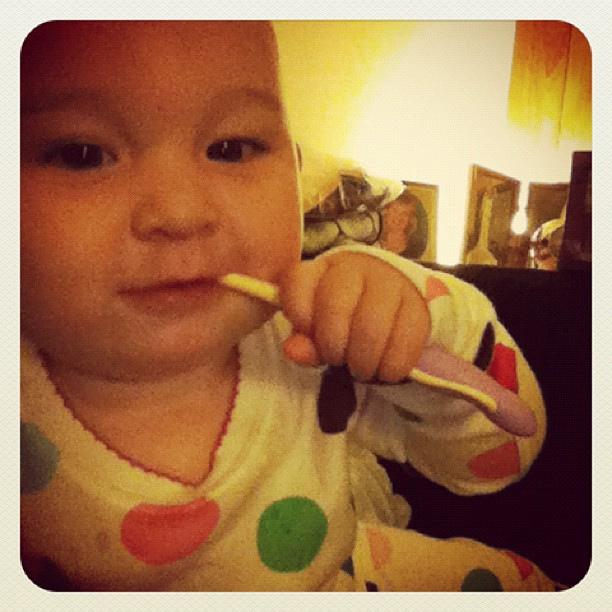Is the baby looking directly into the camera?
Be succinct. Yes. What color hair does the lady have in the framed picture behind the baby?
Quick response, please. Blonde. Is this black and white?
Be succinct. No. Is the person wearing glasses?
Answer briefly. No. Is there an item in this photo that could be used as a weapon?
Keep it brief. No. What is the baby holding?
Short answer required. Toothbrush. What is in the babies mouth?
Concise answer only. Toothbrush. Is this a girl or boy?
Quick response, please. Girl. 